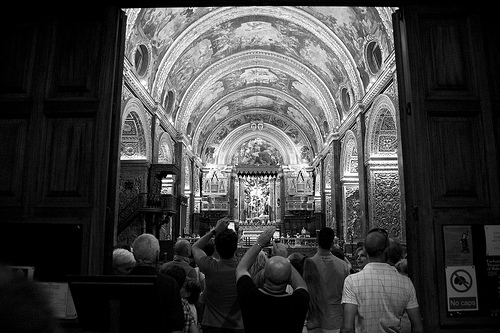What historical significance might this place hold? This church likely holds historical significance as a place of worship and cultural heritage. Its ornate decorations and artistic details suggest it has been an important site for religious ceremonies and possibly a landmark for historical events in the region. 